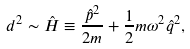Convert formula to latex. <formula><loc_0><loc_0><loc_500><loc_500>d ^ { 2 } \sim \hat { H } \equiv \frac { \hat { p } ^ { 2 } } { 2 m } + \frac { 1 } { 2 } m \omega ^ { 2 } \hat { q } ^ { 2 } ,</formula> 